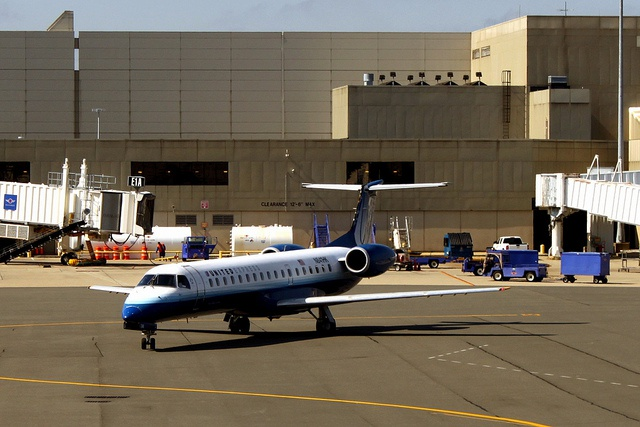Describe the objects in this image and their specific colors. I can see airplane in darkgray, black, white, and gray tones, truck in darkgray, black, navy, blue, and gray tones, truck in darkgray, black, navy, and blue tones, truck in darkgray, black, white, and gray tones, and people in darkgray, black, maroon, gray, and brown tones in this image. 